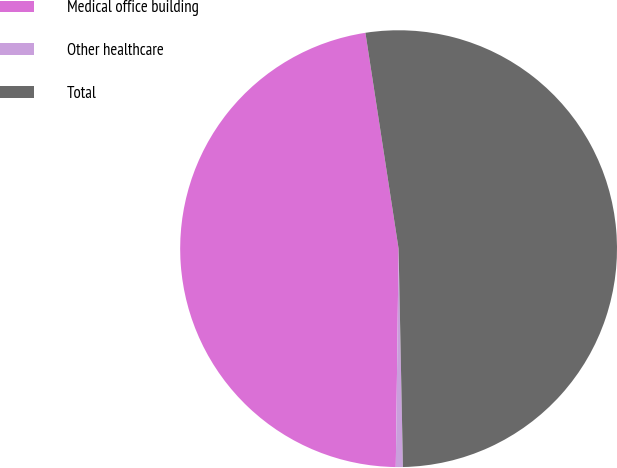Convert chart. <chart><loc_0><loc_0><loc_500><loc_500><pie_chart><fcel>Medical office building<fcel>Other healthcare<fcel>Total<nl><fcel>47.37%<fcel>0.52%<fcel>52.11%<nl></chart> 